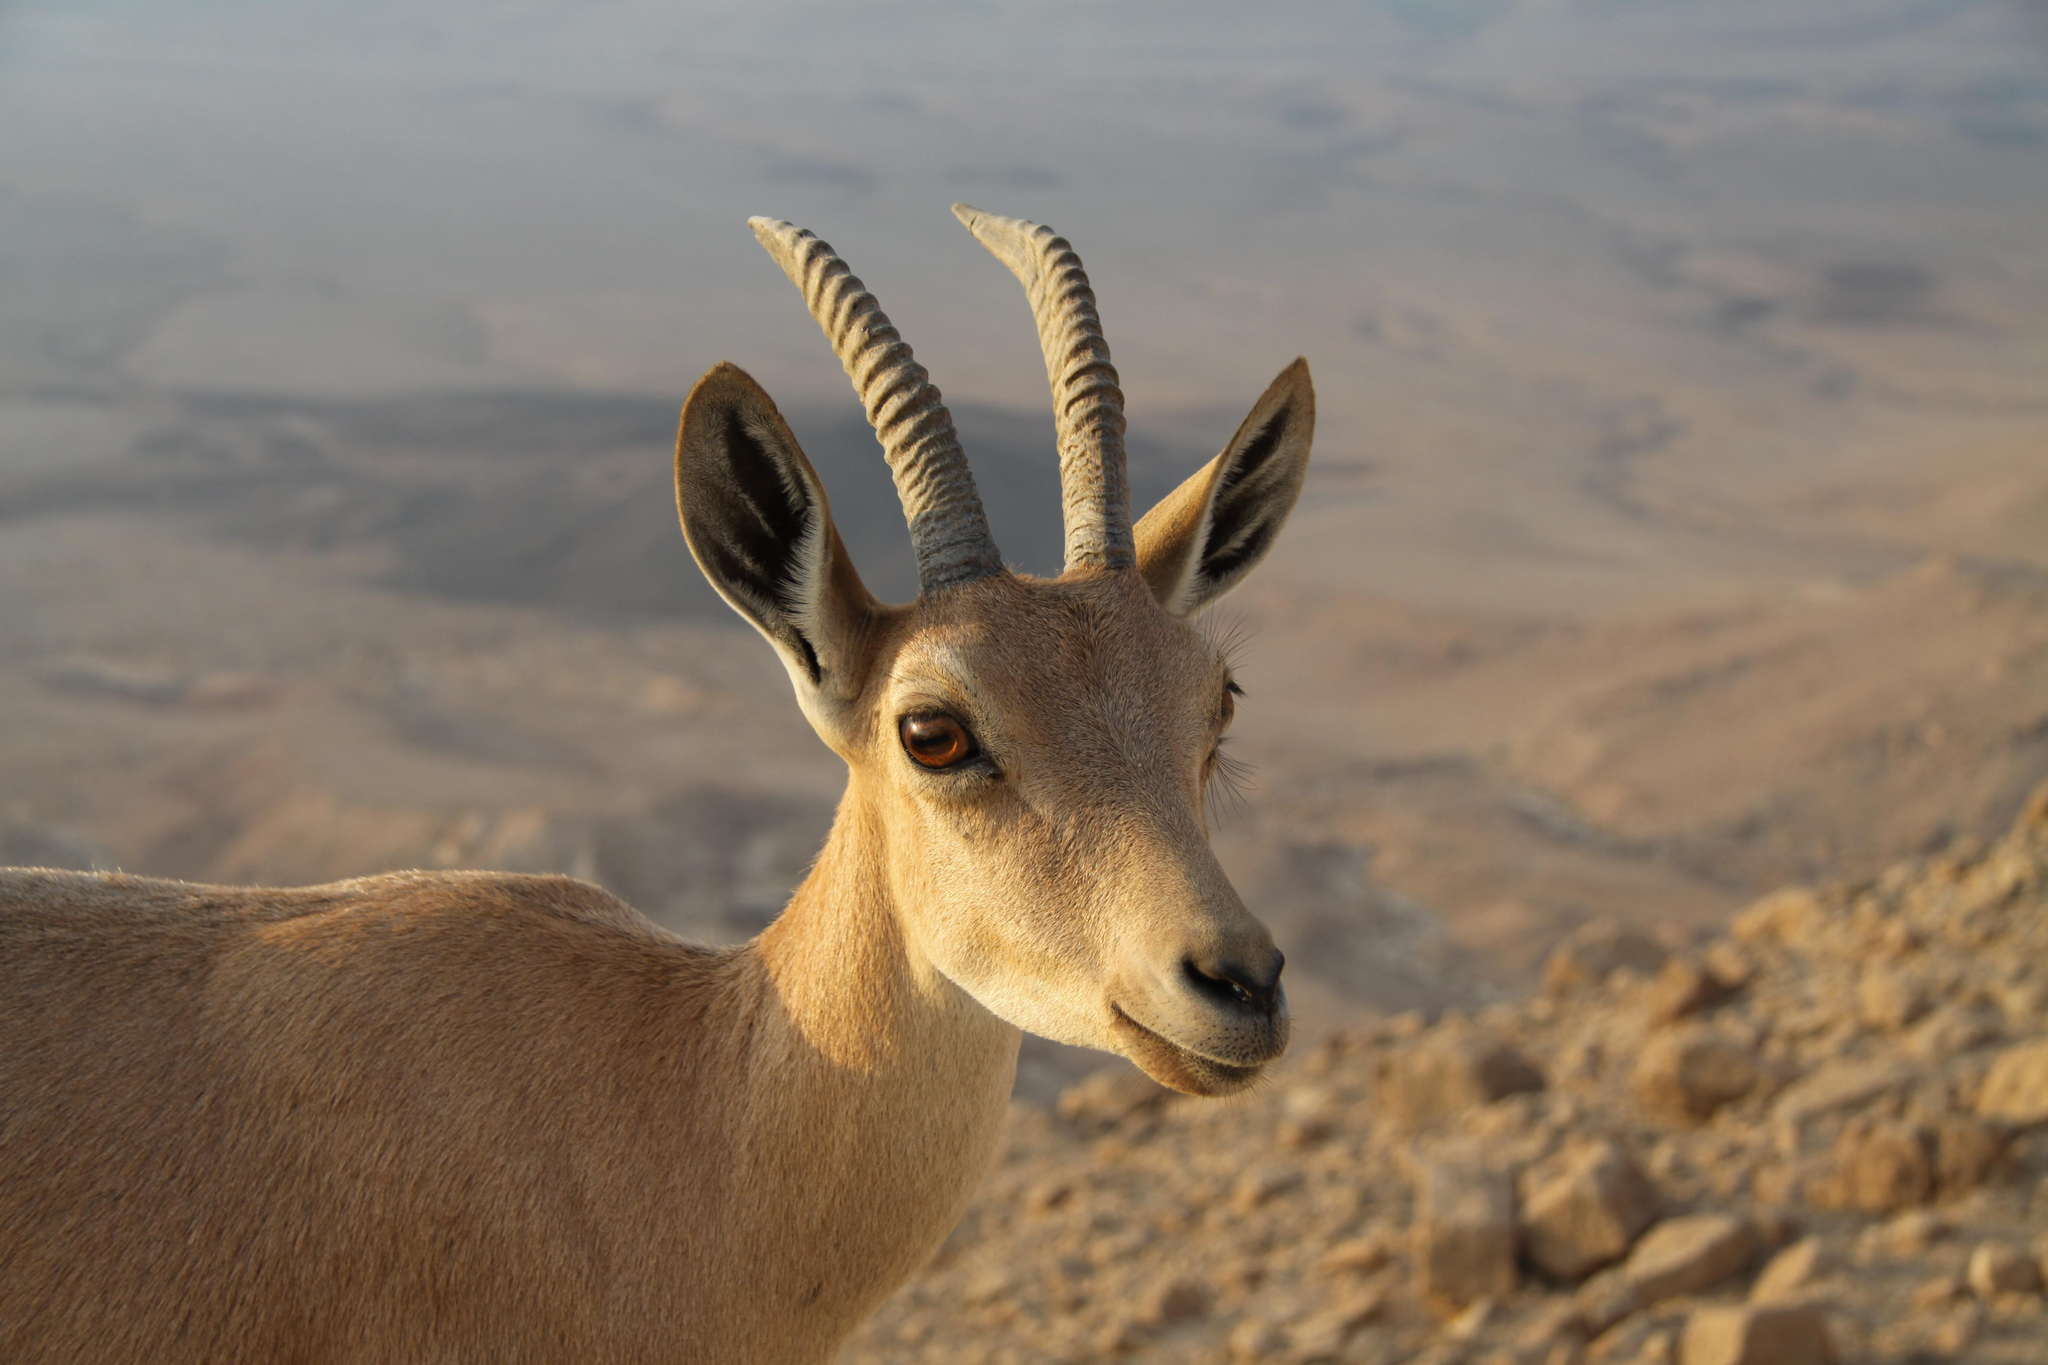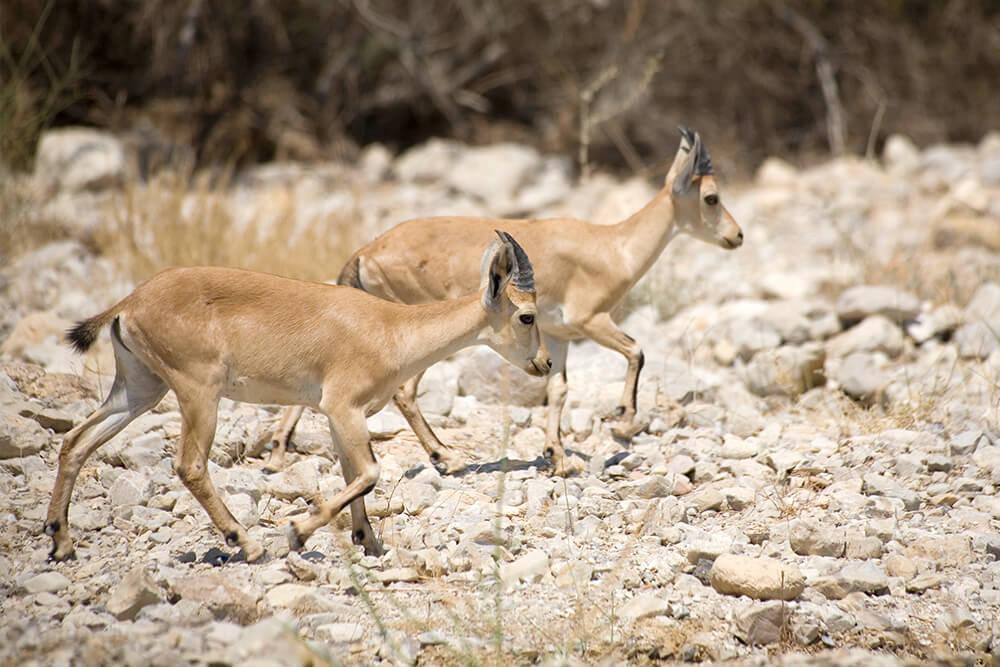The first image is the image on the left, the second image is the image on the right. Analyze the images presented: Is the assertion "There is snow visible." valid? Answer yes or no. No. 